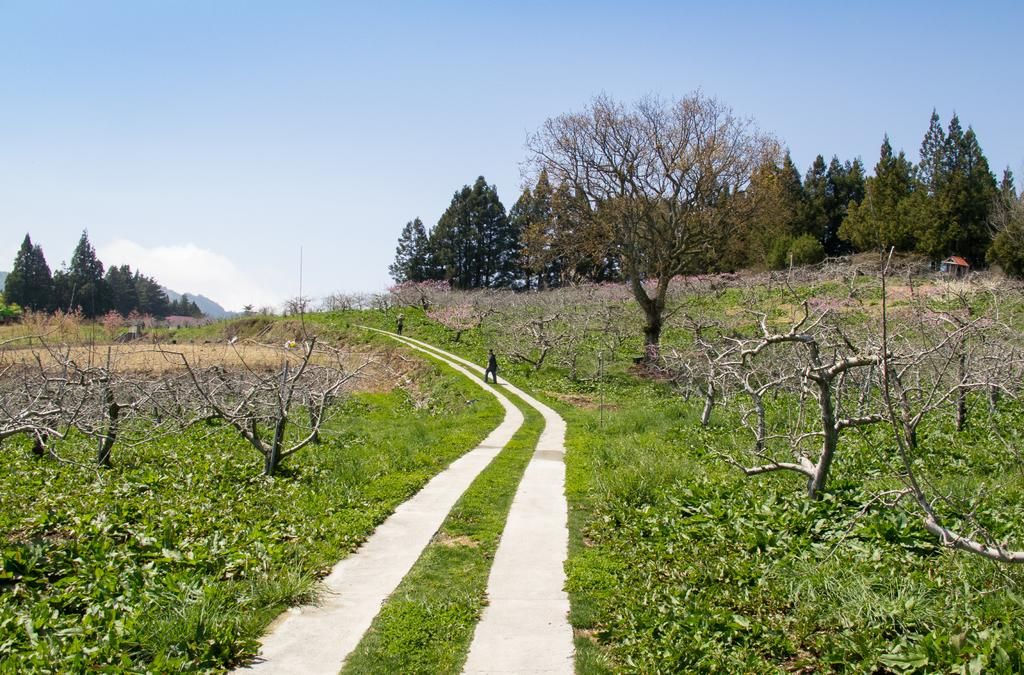How many pathways can be seen in the image? There are two pathways in the image. What type of vegetation is present on both sides of the pathways? Trees and dry trees are present on both sides of the image. What is the terrain like where the pathways are located? The pathways are on grassy land. What is visible at the top of the image? The sky is visible at the top of the image. Can you see any letters on the trees in the image? There are no letters present on the trees in the image. What type of fruit is hanging from the dry trees in the image? There is no fruit hanging from the dry trees in the image. 